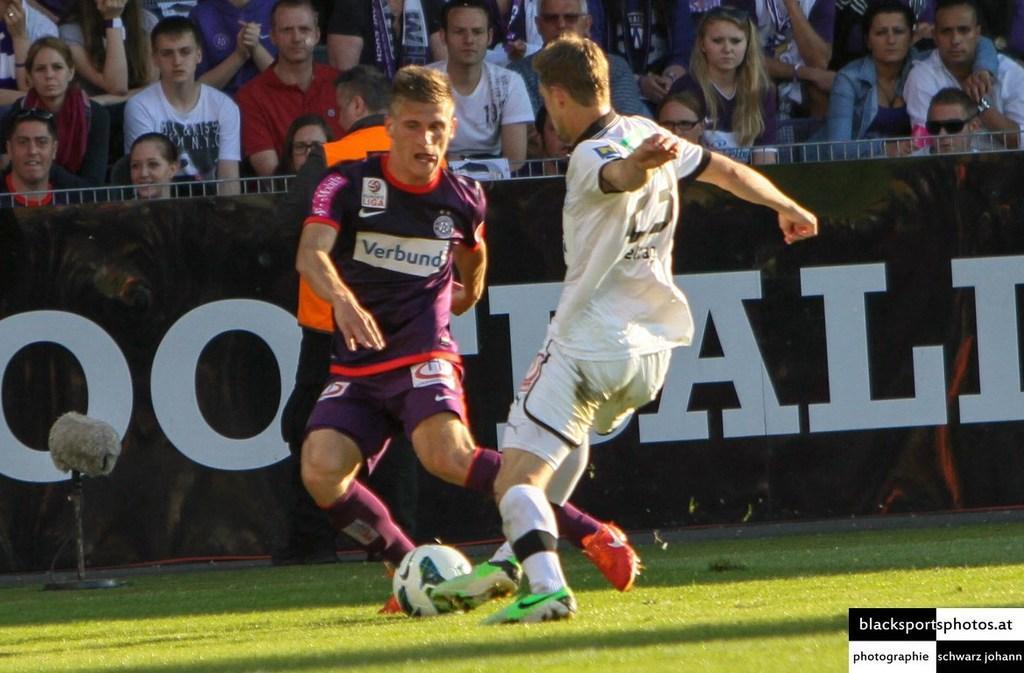In one or two sentences, can you explain what this image depicts? On the background of the picture we can see crowd sitting. This is a hoarding. We can see two men playing a football in a playground. 